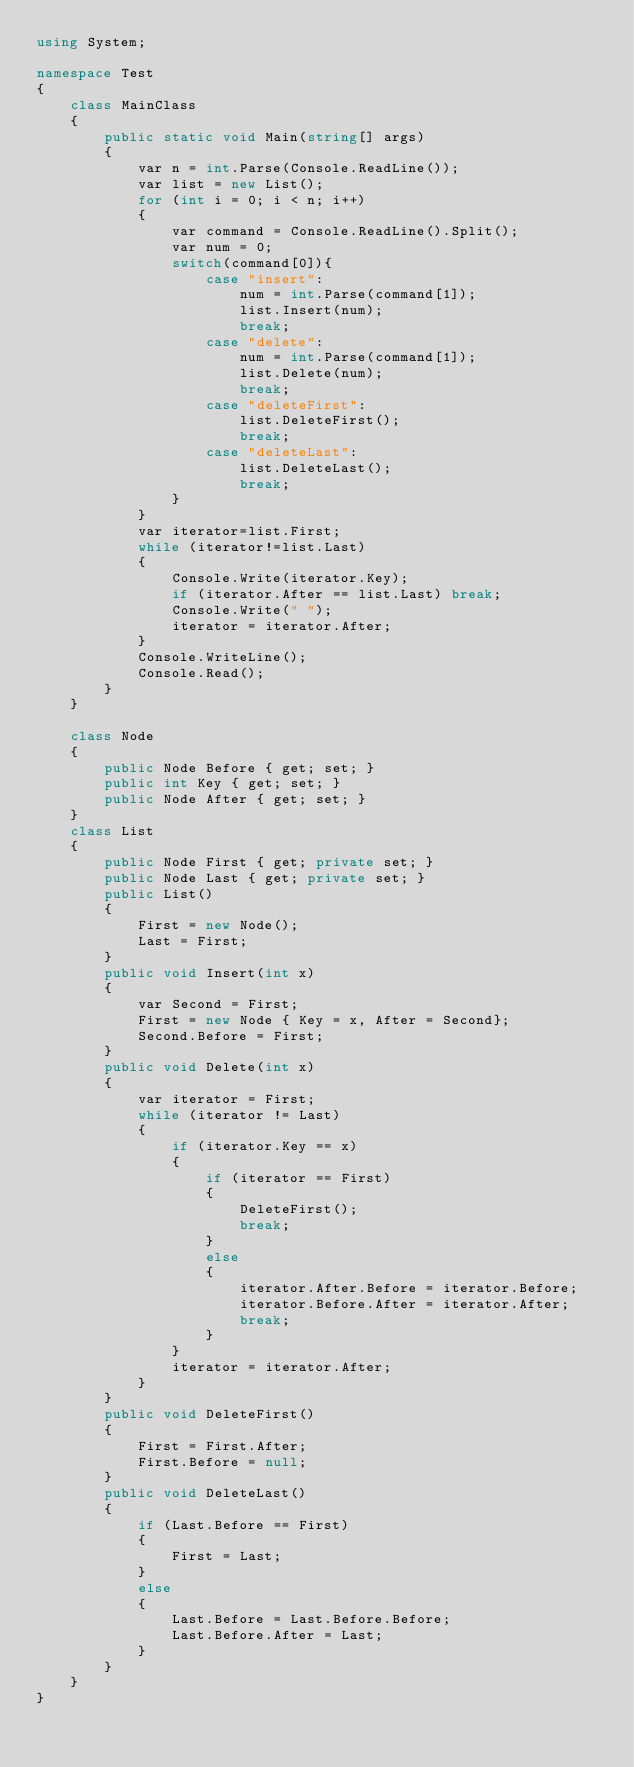<code> <loc_0><loc_0><loc_500><loc_500><_C#_>using System;

namespace Test
{
    class MainClass
    {
        public static void Main(string[] args)
        {
            var n = int.Parse(Console.ReadLine());
            var list = new List();
            for (int i = 0; i < n; i++)
            {
                var command = Console.ReadLine().Split();
                var num = 0;
                switch(command[0]){
                    case "insert":
                        num = int.Parse(command[1]);
                        list.Insert(num);
                        break;
                    case "delete":
                        num = int.Parse(command[1]);
                        list.Delete(num);
                        break;
                    case "deleteFirst":
                        list.DeleteFirst();
                        break;
                    case "deleteLast":
                        list.DeleteLast();
                        break;
                }
            }
            var iterator=list.First;
            while (iterator!=list.Last)
            {
                Console.Write(iterator.Key);
                if (iterator.After == list.Last) break;
                Console.Write(" ");
                iterator = iterator.After;
            }
            Console.WriteLine();
            Console.Read();
        }
    }

    class Node
    {
        public Node Before { get; set; }
        public int Key { get; set; }
        public Node After { get; set; }
    }
    class List
    {
        public Node First { get; private set; }
        public Node Last { get; private set; }
        public List()
        {
            First = new Node();
            Last = First;
        }
        public void Insert(int x)
        {
            var Second = First;
            First = new Node { Key = x, After = Second};
            Second.Before = First;
        }
        public void Delete(int x)
        {
            var iterator = First;
            while (iterator != Last)
            {
                if (iterator.Key == x)
                {
                    if (iterator == First)
                    {
                        DeleteFirst();
                        break;
                    }
                    else
                    {
                        iterator.After.Before = iterator.Before;
                        iterator.Before.After = iterator.After;
                        break;
                    }
                }
                iterator = iterator.After;
            }
        }
        public void DeleteFirst()
        {
            First = First.After;
            First.Before = null;
        }
        public void DeleteLast()
        {
            if (Last.Before == First)
            {
                First = Last;
            }
            else
            {
                Last.Before = Last.Before.Before;
                Last.Before.After = Last;
            }
        }
    }
}</code> 